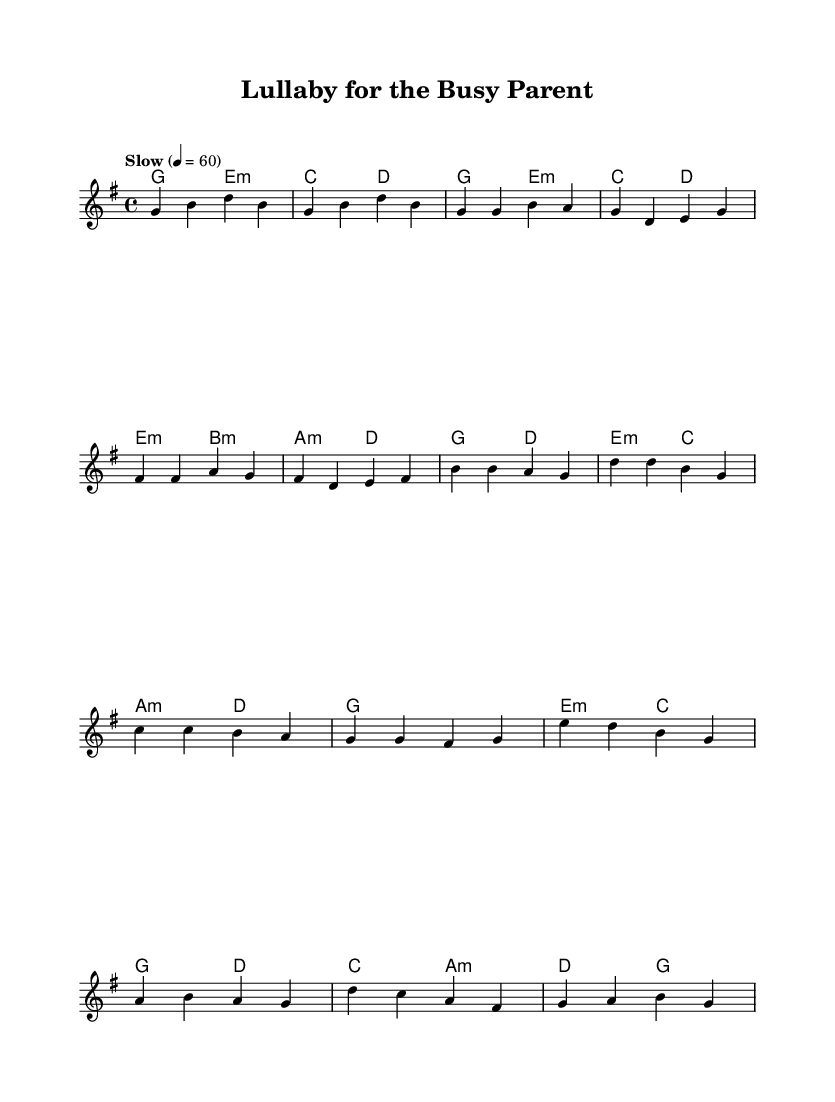What is the key signature of this music? The key signature is G major, which has one sharp (F#) indicated at the beginning of the staff.
Answer: G major What is the time signature of this music? The time signature given at the beginning of the sheet music is 4/4, meaning there are four beats in each measure and the quarter note gets one beat.
Answer: 4/4 What is the tempo marking for this piece? The tempo marking states "Slow" with a metronome marking of 60, indicating that the piece should be played slowly at 60 beats per minute.
Answer: 60 What is the name of this composition? The title provided in the header of the sheet music is "Lullaby for the Busy Parent."
Answer: Lullaby for the Busy Parent How many sections are there in this song? The song consists of an intro, a verse, a chorus, and a bridge, making it four distinct sections.
Answer: Four Which chord appears in the chorus? The chorus features the following chords: G, D, E minor, and C, with the G chord being the root of the section.
Answer: G What is the structure of this pop ballad? The structure includes an intro, followed by verse 1, then a chorus, and it is concluded with a bridge before returning to the chorus.
Answer: Intro, Verse 1, Chorus, Bridge 